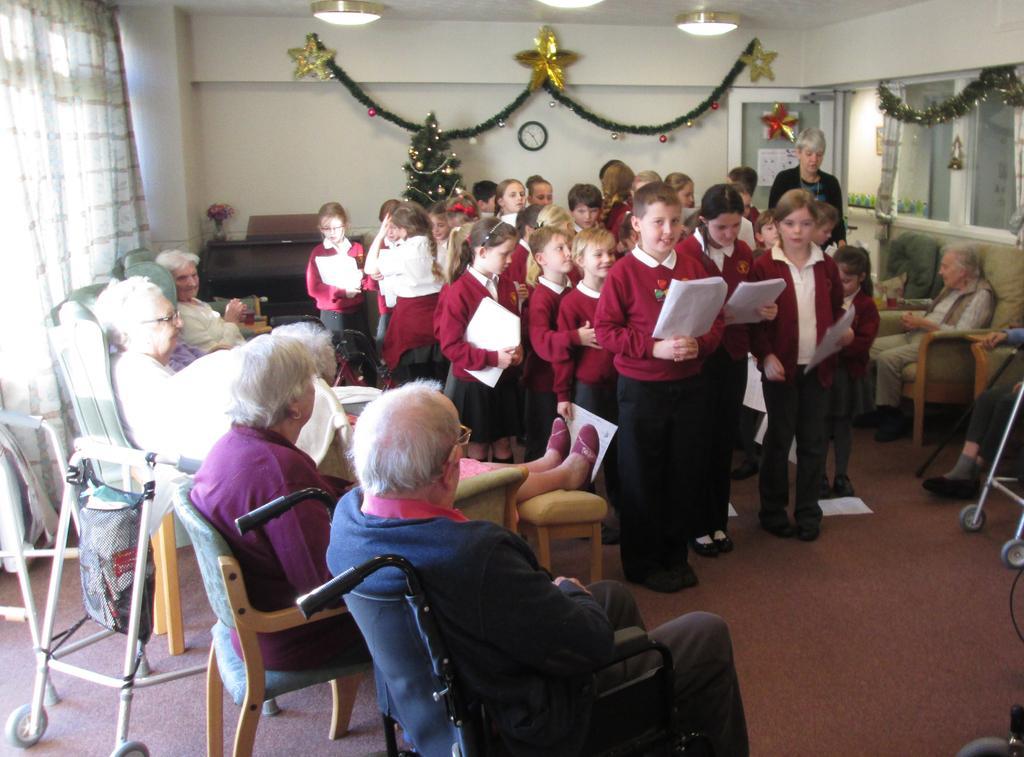In one or two sentences, can you explain what this image depicts? In this image i can see some of the senior citizen sitting on the chairs and few children standing in front of them holding papers in their hands. In the background i can see some Christmas decorating, a wall, a clock , some lights to the ceiling and a curtain. 